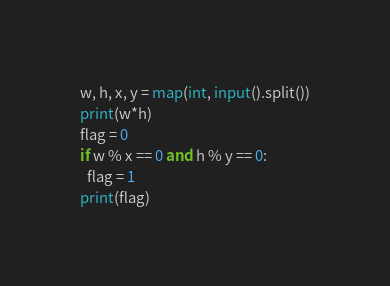Convert code to text. <code><loc_0><loc_0><loc_500><loc_500><_Python_>w, h, x, y = map(int, input().split())
print(w*h)
flag = 0
if w % x == 0 and h % y == 0:
  flag = 1
print(flag)</code> 